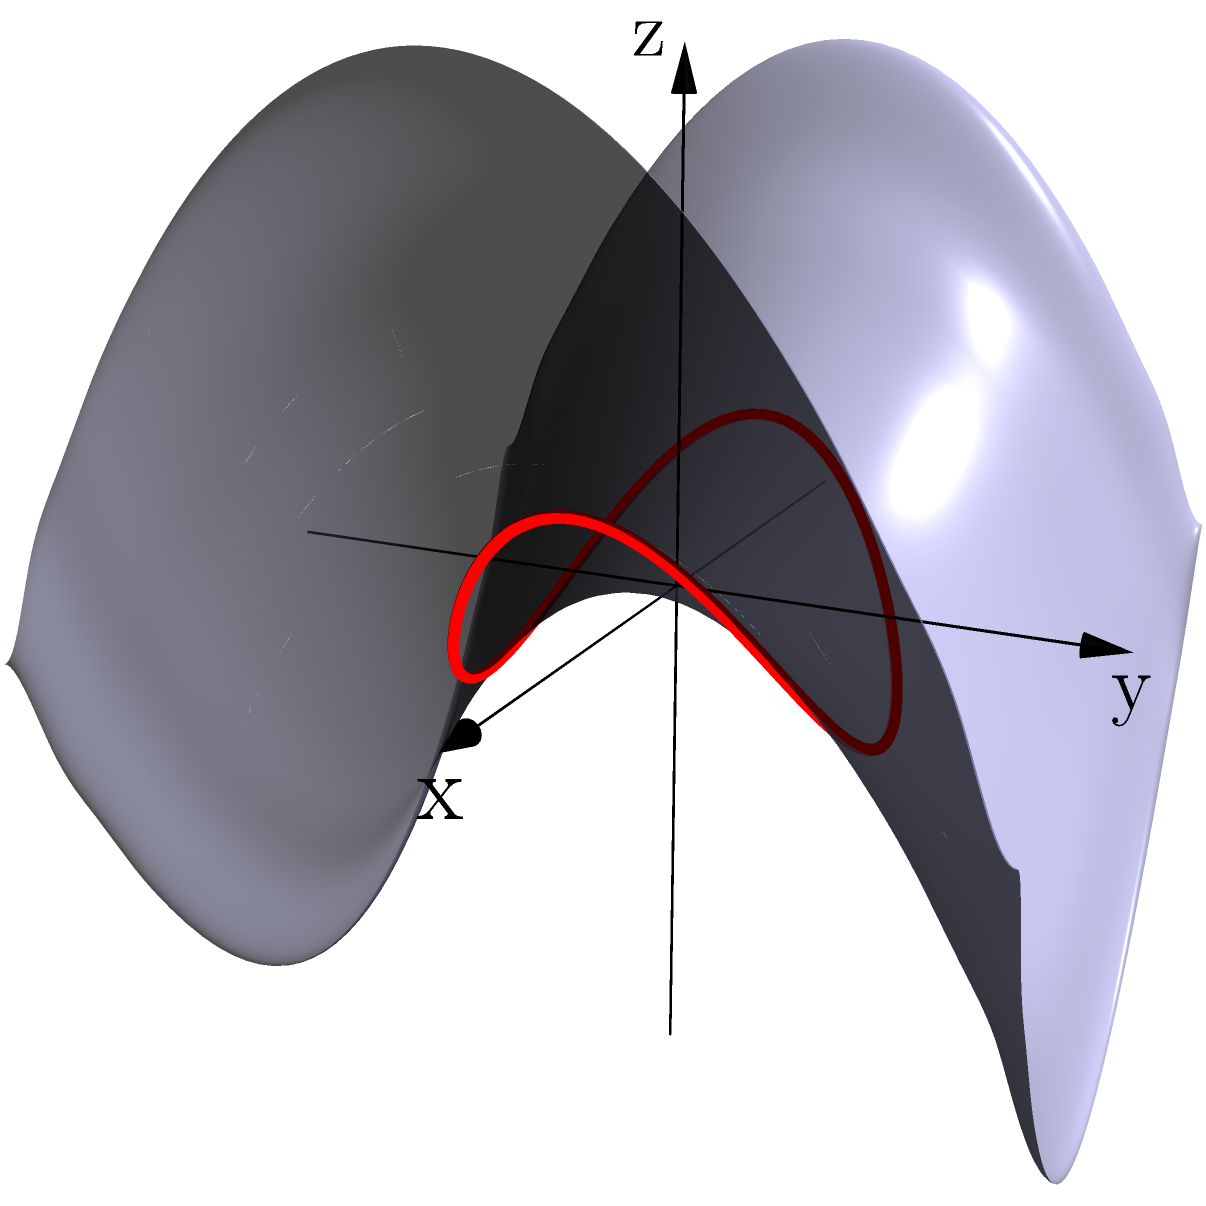In the context of Non-Euclidean Geometry, consider a saddle-shaped surface represented by the equation $z = x^2 - y^2$. A geodesic on this surface follows a circular path when projected onto the xy-plane. What is the general form of the parametric equations for this geodesic in terms of a parameter $t$? To find the parametric equations for the geodesic, we can follow these steps:

1. Recognize that the surface is given by $z = x^2 - y^2$.

2. The geodesic projects to a circle on the xy-plane. A general parametric form for a circle is:
   $x = r \cos(t)$
   $y = r \sin(t)$
   where $r$ is the radius and $t$ is the parameter.

3. To find $z$, substitute these $x$ and $y$ into the surface equation:
   $z = x^2 - y^2 = (r \cos(t))^2 - (r \sin(t))^2$

4. Simplify using trigonometric identities:
   $z = r^2 (\cos^2(t) - \sin^2(t)) = r^2 \cos(2t)$

5. Therefore, the parametric equations for the geodesic are:
   $x = r \cos(t)$
   $y = r \sin(t)$
   $z = r^2 \cos(2t)$

These equations describe a geodesic that follows a circular path when projected onto the xy-plane, while oscillating in the z-direction with twice the frequency.
Answer: $x = r \cos(t)$, $y = r \sin(t)$, $z = r^2 \cos(2t)$ 